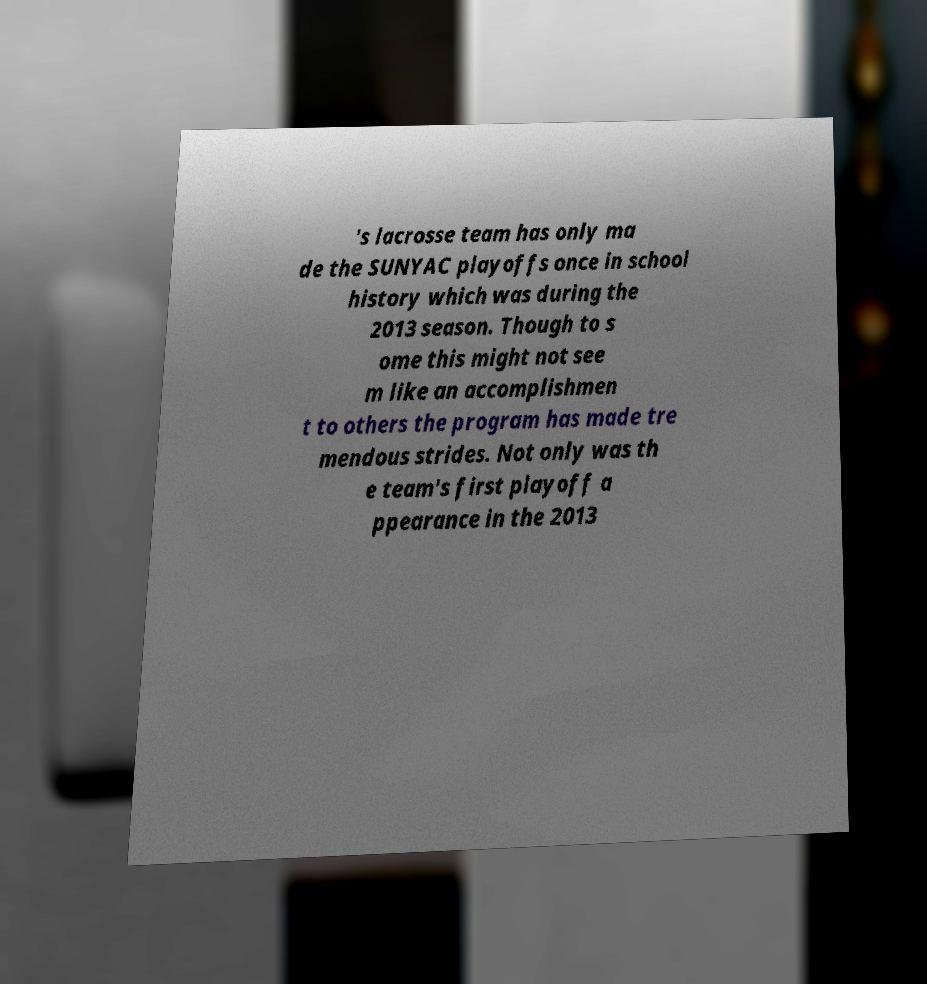Please read and relay the text visible in this image. What does it say? 's lacrosse team has only ma de the SUNYAC playoffs once in school history which was during the 2013 season. Though to s ome this might not see m like an accomplishmen t to others the program has made tre mendous strides. Not only was th e team's first playoff a ppearance in the 2013 